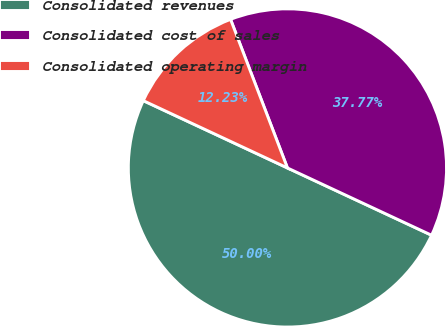Convert chart. <chart><loc_0><loc_0><loc_500><loc_500><pie_chart><fcel>Consolidated revenues<fcel>Consolidated cost of sales<fcel>Consolidated operating margin<nl><fcel>50.0%<fcel>37.77%<fcel>12.23%<nl></chart> 